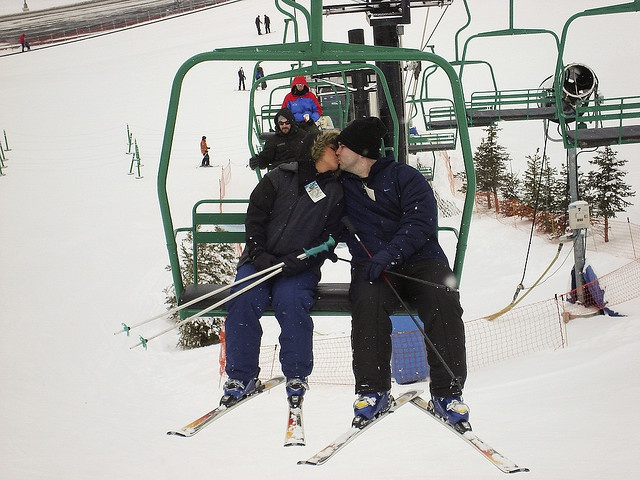Describe the objects in this image and their specific colors. I can see people in lightgray, black, gray, and navy tones, people in lightgray, black, navy, white, and gray tones, bench in lightgray, black, gray, and darkgreen tones, bench in lightgray, gray, white, black, and teal tones, and skis in lightgray, darkgray, and gray tones in this image. 